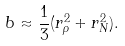<formula> <loc_0><loc_0><loc_500><loc_500>b \approx \frac { 1 } { 3 } ( r _ { \rho } ^ { 2 } + r _ { N } ^ { 2 } ) .</formula> 